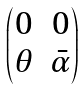<formula> <loc_0><loc_0><loc_500><loc_500>\begin{pmatrix} 0 & 0 \\ \theta & \bar { \alpha } \end{pmatrix}</formula> 